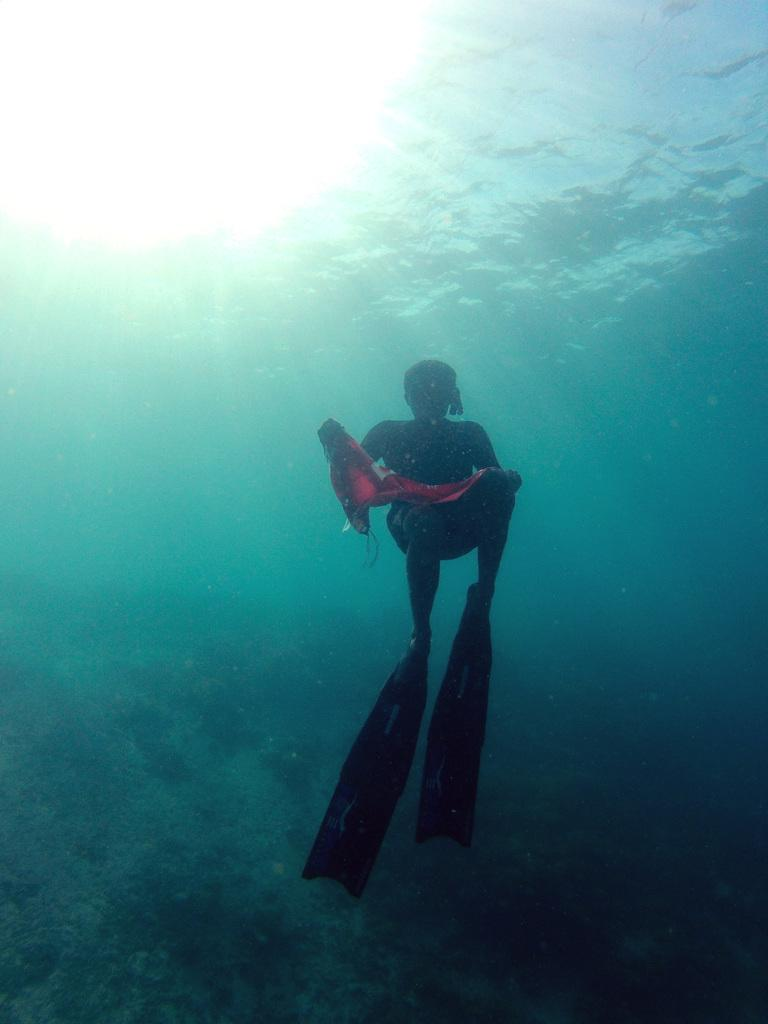What is the person in the image doing? The person is swimming in the image. Where is the person located in the image? The person is in the water. What type of environment is depicted in the image? The image depicts an underwater environment. What color is the chalk used by the representative in the image? There is no representative or chalk present in the image; it depicts a person swimming in an underwater environment. 